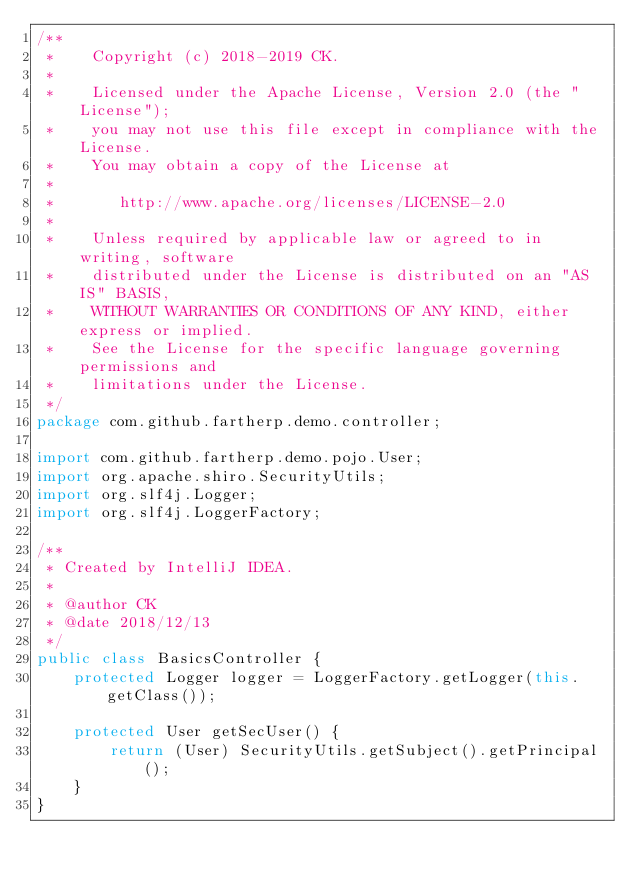Convert code to text. <code><loc_0><loc_0><loc_500><loc_500><_Java_>/**
 *    Copyright (c) 2018-2019 CK.
 *
 *    Licensed under the Apache License, Version 2.0 (the "License");
 *    you may not use this file except in compliance with the License.
 *    You may obtain a copy of the License at
 *
 *       http://www.apache.org/licenses/LICENSE-2.0
 *
 *    Unless required by applicable law or agreed to in writing, software
 *    distributed under the License is distributed on an "AS IS" BASIS,
 *    WITHOUT WARRANTIES OR CONDITIONS OF ANY KIND, either express or implied.
 *    See the License for the specific language governing permissions and
 *    limitations under the License.
 */
package com.github.fartherp.demo.controller;

import com.github.fartherp.demo.pojo.User;
import org.apache.shiro.SecurityUtils;
import org.slf4j.Logger;
import org.slf4j.LoggerFactory;

/**
 * Created by IntelliJ IDEA.
 *
 * @author CK
 * @date 2018/12/13
 */
public class BasicsController {
    protected Logger logger = LoggerFactory.getLogger(this.getClass());

    protected User getSecUser() {
        return (User) SecurityUtils.getSubject().getPrincipal();
    }
}
</code> 